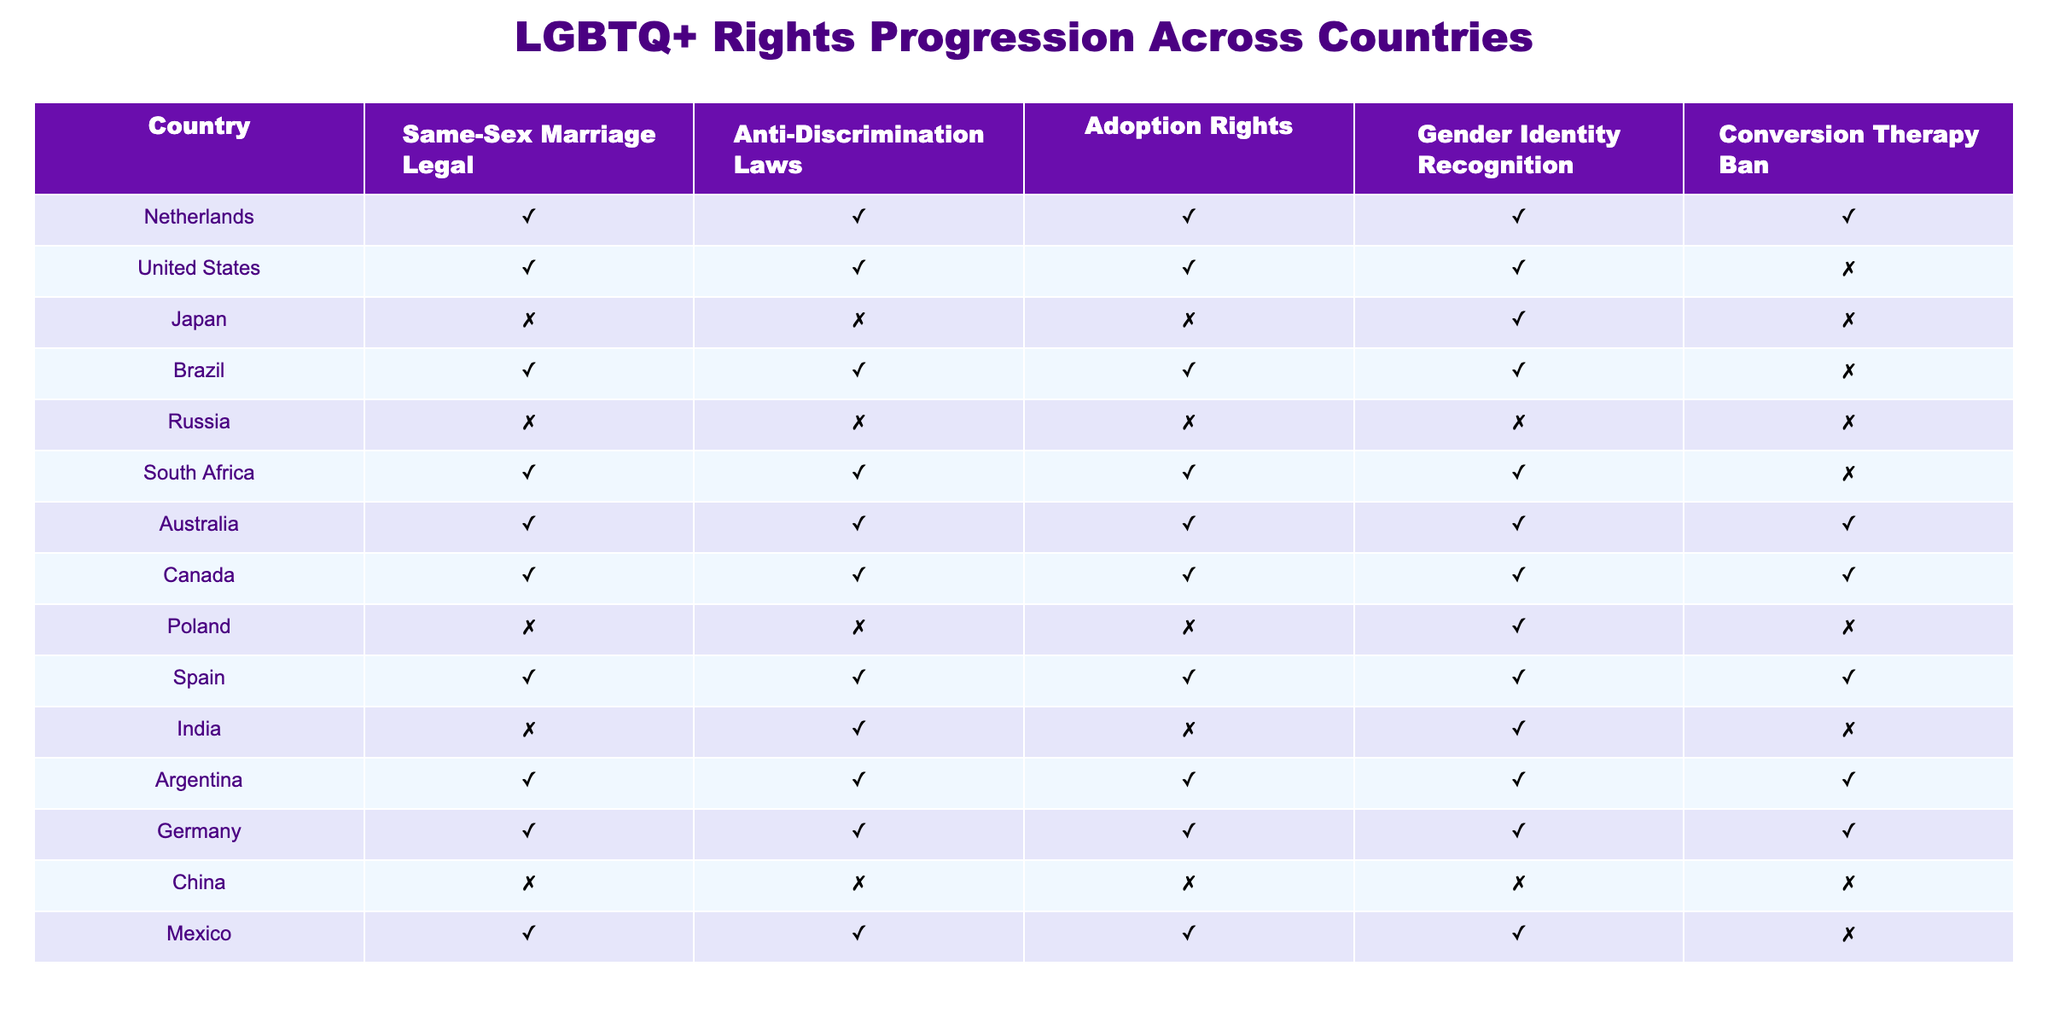What countries have legalized same-sex marriage? By examining the "Same-Sex Marriage Legal" column, we can easily identify that the countries marked as TRUE are Netherlands, United States, Brazil, South Africa, Australia, Canada, Spain, Argentina, Germany, and Mexico.
Answer: Netherlands, United States, Brazil, South Africa, Australia, Canada, Spain, Argentina, Germany, Mexico Which country is the only one to have a conversion therapy ban while having other rights like same-sex marriage? Looking at the "Conversion Therapy Ban" column, Australia is marked as TRUE, and upon checking the other columns, it also has TRUE values for same-sex marriage, anti-discrimination laws, adoption rights, and gender identity recognition. Therefore, it is the only country meeting these criteria.
Answer: Australia Count the number of countries that recognize gender identity. By counting the entries marked as TRUE in the "Gender Identity Recognition" column, there are 6 countries: Netherlands, Japan, Brazil, South Africa, Argentina, and Germany.
Answer: 6 Is conversion therapy banned in Japan? Consulting the "Conversion Therapy Ban" column for Japan shows it marked as FALSE. Therefore, it indicates that conversion therapy is not banned in Japan.
Answer: No Which country has the fewest LGBTQ+ rights according to the table? By analyzing the rows, we see that Russia and China have all their columns marked as FALSE, indicating they have the fewest rights. Since both have the same score, either could be considered; however, Russia has a broader range of social repression issues recognized internationally.
Answer: Russia Are there any countries that have adoption rights but do not have same-sex marriage legalized? By comparing the "Adoption Rights" and "Same-Sex Marriage Legal" columns, we find India as the only country where adoption rights are marked TRUE but same-sex marriage is FALSE.
Answer: Yes, India How many countries are there that have anti-discrimination laws? Looking at the "Anti-Discrimination Laws" column, we can identify the countries marked as TRUE. The countries are Netherlands, United States, Brazil, South Africa, Australia, Canada, Spain, India, and Mexico, leading to a total of 9 countries.
Answer: 9 What is the relationship between countries that allowed same-sex marriage and banning conversion therapy? By analyzing the table, we find that out of the countries that legalized same-sex marriage (10 countries), only 5 also have a ban on conversion therapy, indicating a positive correlation but not a direct relationship.
Answer: Positive correlation, not direct Which country allows same-sex marriage but does not recognize gender identity? By checking the "Same-Sex Marriage Legal" column for TRUE and the "Gender Identity Recognition" column for FALSE, Poland fits this criteria.
Answer: Poland 